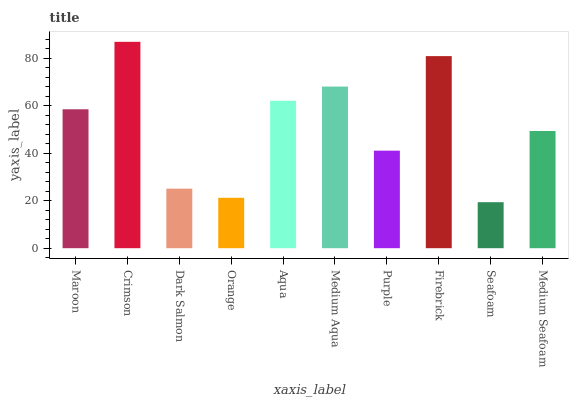Is Seafoam the minimum?
Answer yes or no. Yes. Is Crimson the maximum?
Answer yes or no. Yes. Is Dark Salmon the minimum?
Answer yes or no. No. Is Dark Salmon the maximum?
Answer yes or no. No. Is Crimson greater than Dark Salmon?
Answer yes or no. Yes. Is Dark Salmon less than Crimson?
Answer yes or no. Yes. Is Dark Salmon greater than Crimson?
Answer yes or no. No. Is Crimson less than Dark Salmon?
Answer yes or no. No. Is Maroon the high median?
Answer yes or no. Yes. Is Medium Seafoam the low median?
Answer yes or no. Yes. Is Aqua the high median?
Answer yes or no. No. Is Purple the low median?
Answer yes or no. No. 